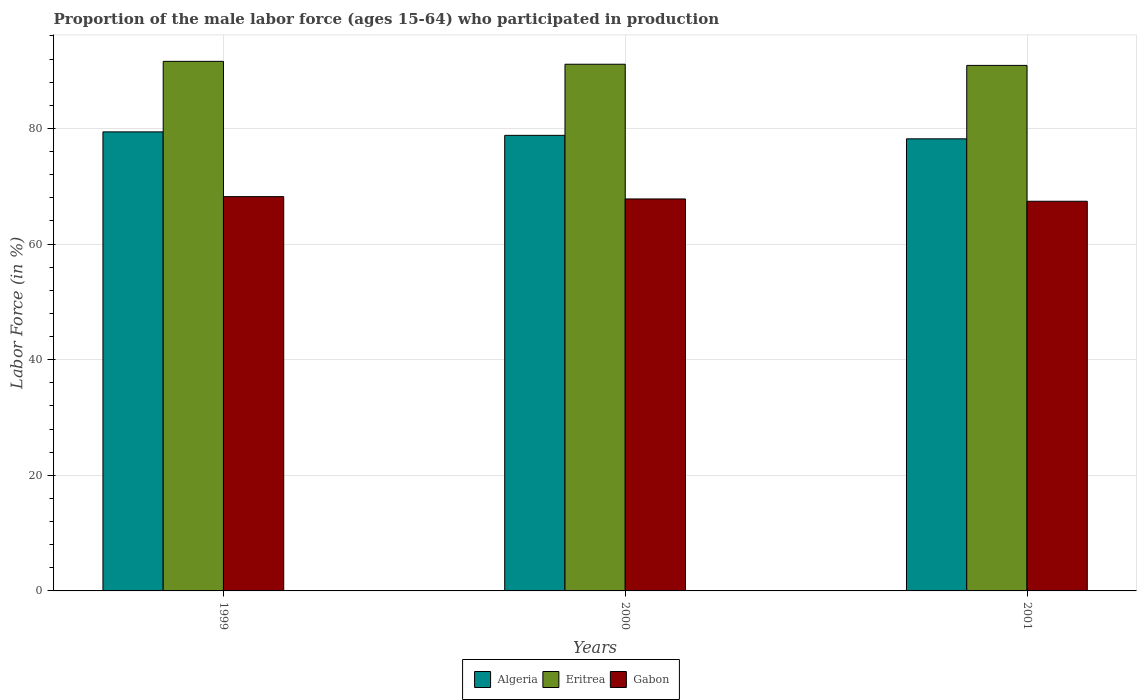How many different coloured bars are there?
Make the answer very short. 3. How many groups of bars are there?
Offer a terse response. 3. Are the number of bars per tick equal to the number of legend labels?
Offer a terse response. Yes. In how many cases, is the number of bars for a given year not equal to the number of legend labels?
Offer a terse response. 0. What is the proportion of the male labor force who participated in production in Algeria in 2001?
Your answer should be very brief. 78.2. Across all years, what is the maximum proportion of the male labor force who participated in production in Eritrea?
Provide a succinct answer. 91.6. Across all years, what is the minimum proportion of the male labor force who participated in production in Gabon?
Provide a short and direct response. 67.4. In which year was the proportion of the male labor force who participated in production in Gabon maximum?
Offer a very short reply. 1999. In which year was the proportion of the male labor force who participated in production in Eritrea minimum?
Your answer should be compact. 2001. What is the total proportion of the male labor force who participated in production in Eritrea in the graph?
Give a very brief answer. 273.6. What is the difference between the proportion of the male labor force who participated in production in Eritrea in 1999 and that in 2001?
Make the answer very short. 0.7. What is the difference between the proportion of the male labor force who participated in production in Eritrea in 2000 and the proportion of the male labor force who participated in production in Algeria in 1999?
Make the answer very short. 11.7. What is the average proportion of the male labor force who participated in production in Eritrea per year?
Provide a short and direct response. 91.2. In the year 2000, what is the difference between the proportion of the male labor force who participated in production in Eritrea and proportion of the male labor force who participated in production in Algeria?
Provide a short and direct response. 12.3. In how many years, is the proportion of the male labor force who participated in production in Gabon greater than 52 %?
Your response must be concise. 3. What is the ratio of the proportion of the male labor force who participated in production in Algeria in 1999 to that in 2000?
Your answer should be very brief. 1.01. What is the difference between the highest and the second highest proportion of the male labor force who participated in production in Algeria?
Provide a succinct answer. 0.6. What is the difference between the highest and the lowest proportion of the male labor force who participated in production in Gabon?
Keep it short and to the point. 0.8. What does the 2nd bar from the left in 2000 represents?
Your answer should be compact. Eritrea. What does the 1st bar from the right in 2000 represents?
Offer a very short reply. Gabon. How many bars are there?
Make the answer very short. 9. What is the difference between two consecutive major ticks on the Y-axis?
Provide a succinct answer. 20. Are the values on the major ticks of Y-axis written in scientific E-notation?
Keep it short and to the point. No. Does the graph contain any zero values?
Provide a succinct answer. No. Does the graph contain grids?
Your answer should be compact. Yes. Where does the legend appear in the graph?
Keep it short and to the point. Bottom center. How many legend labels are there?
Keep it short and to the point. 3. How are the legend labels stacked?
Give a very brief answer. Horizontal. What is the title of the graph?
Your answer should be very brief. Proportion of the male labor force (ages 15-64) who participated in production. Does "Angola" appear as one of the legend labels in the graph?
Offer a very short reply. No. What is the label or title of the X-axis?
Offer a terse response. Years. What is the Labor Force (in %) in Algeria in 1999?
Provide a short and direct response. 79.4. What is the Labor Force (in %) of Eritrea in 1999?
Offer a terse response. 91.6. What is the Labor Force (in %) in Gabon in 1999?
Offer a very short reply. 68.2. What is the Labor Force (in %) in Algeria in 2000?
Your response must be concise. 78.8. What is the Labor Force (in %) of Eritrea in 2000?
Give a very brief answer. 91.1. What is the Labor Force (in %) in Gabon in 2000?
Your answer should be very brief. 67.8. What is the Labor Force (in %) in Algeria in 2001?
Ensure brevity in your answer.  78.2. What is the Labor Force (in %) in Eritrea in 2001?
Your answer should be very brief. 90.9. What is the Labor Force (in %) in Gabon in 2001?
Keep it short and to the point. 67.4. Across all years, what is the maximum Labor Force (in %) in Algeria?
Give a very brief answer. 79.4. Across all years, what is the maximum Labor Force (in %) in Eritrea?
Provide a short and direct response. 91.6. Across all years, what is the maximum Labor Force (in %) in Gabon?
Make the answer very short. 68.2. Across all years, what is the minimum Labor Force (in %) in Algeria?
Ensure brevity in your answer.  78.2. Across all years, what is the minimum Labor Force (in %) of Eritrea?
Provide a succinct answer. 90.9. Across all years, what is the minimum Labor Force (in %) in Gabon?
Make the answer very short. 67.4. What is the total Labor Force (in %) in Algeria in the graph?
Keep it short and to the point. 236.4. What is the total Labor Force (in %) of Eritrea in the graph?
Your answer should be compact. 273.6. What is the total Labor Force (in %) in Gabon in the graph?
Provide a short and direct response. 203.4. What is the difference between the Labor Force (in %) of Algeria in 1999 and that in 2000?
Your answer should be very brief. 0.6. What is the difference between the Labor Force (in %) in Algeria in 1999 and that in 2001?
Your answer should be very brief. 1.2. What is the difference between the Labor Force (in %) of Algeria in 2000 and that in 2001?
Offer a terse response. 0.6. What is the difference between the Labor Force (in %) of Gabon in 2000 and that in 2001?
Keep it short and to the point. 0.4. What is the difference between the Labor Force (in %) of Algeria in 1999 and the Labor Force (in %) of Eritrea in 2000?
Give a very brief answer. -11.7. What is the difference between the Labor Force (in %) of Algeria in 1999 and the Labor Force (in %) of Gabon in 2000?
Provide a short and direct response. 11.6. What is the difference between the Labor Force (in %) of Eritrea in 1999 and the Labor Force (in %) of Gabon in 2000?
Ensure brevity in your answer.  23.8. What is the difference between the Labor Force (in %) of Algeria in 1999 and the Labor Force (in %) of Gabon in 2001?
Give a very brief answer. 12. What is the difference between the Labor Force (in %) of Eritrea in 1999 and the Labor Force (in %) of Gabon in 2001?
Keep it short and to the point. 24.2. What is the difference between the Labor Force (in %) of Algeria in 2000 and the Labor Force (in %) of Eritrea in 2001?
Your response must be concise. -12.1. What is the difference between the Labor Force (in %) of Algeria in 2000 and the Labor Force (in %) of Gabon in 2001?
Offer a very short reply. 11.4. What is the difference between the Labor Force (in %) in Eritrea in 2000 and the Labor Force (in %) in Gabon in 2001?
Give a very brief answer. 23.7. What is the average Labor Force (in %) in Algeria per year?
Offer a very short reply. 78.8. What is the average Labor Force (in %) in Eritrea per year?
Offer a terse response. 91.2. What is the average Labor Force (in %) of Gabon per year?
Offer a terse response. 67.8. In the year 1999, what is the difference between the Labor Force (in %) of Algeria and Labor Force (in %) of Eritrea?
Make the answer very short. -12.2. In the year 1999, what is the difference between the Labor Force (in %) in Algeria and Labor Force (in %) in Gabon?
Your answer should be very brief. 11.2. In the year 1999, what is the difference between the Labor Force (in %) in Eritrea and Labor Force (in %) in Gabon?
Ensure brevity in your answer.  23.4. In the year 2000, what is the difference between the Labor Force (in %) in Eritrea and Labor Force (in %) in Gabon?
Your answer should be compact. 23.3. In the year 2001, what is the difference between the Labor Force (in %) in Algeria and Labor Force (in %) in Eritrea?
Make the answer very short. -12.7. In the year 2001, what is the difference between the Labor Force (in %) of Algeria and Labor Force (in %) of Gabon?
Ensure brevity in your answer.  10.8. In the year 2001, what is the difference between the Labor Force (in %) in Eritrea and Labor Force (in %) in Gabon?
Make the answer very short. 23.5. What is the ratio of the Labor Force (in %) of Algeria in 1999 to that in 2000?
Ensure brevity in your answer.  1.01. What is the ratio of the Labor Force (in %) in Eritrea in 1999 to that in 2000?
Offer a very short reply. 1.01. What is the ratio of the Labor Force (in %) of Gabon in 1999 to that in 2000?
Make the answer very short. 1.01. What is the ratio of the Labor Force (in %) of Algeria in 1999 to that in 2001?
Give a very brief answer. 1.02. What is the ratio of the Labor Force (in %) of Eritrea in 1999 to that in 2001?
Ensure brevity in your answer.  1.01. What is the ratio of the Labor Force (in %) in Gabon in 1999 to that in 2001?
Provide a succinct answer. 1.01. What is the ratio of the Labor Force (in %) of Algeria in 2000 to that in 2001?
Your response must be concise. 1.01. What is the ratio of the Labor Force (in %) of Eritrea in 2000 to that in 2001?
Give a very brief answer. 1. What is the ratio of the Labor Force (in %) in Gabon in 2000 to that in 2001?
Ensure brevity in your answer.  1.01. What is the difference between the highest and the second highest Labor Force (in %) in Eritrea?
Provide a short and direct response. 0.5. What is the difference between the highest and the second highest Labor Force (in %) in Gabon?
Offer a very short reply. 0.4. What is the difference between the highest and the lowest Labor Force (in %) in Algeria?
Your answer should be compact. 1.2. What is the difference between the highest and the lowest Labor Force (in %) of Eritrea?
Make the answer very short. 0.7. What is the difference between the highest and the lowest Labor Force (in %) in Gabon?
Offer a very short reply. 0.8. 